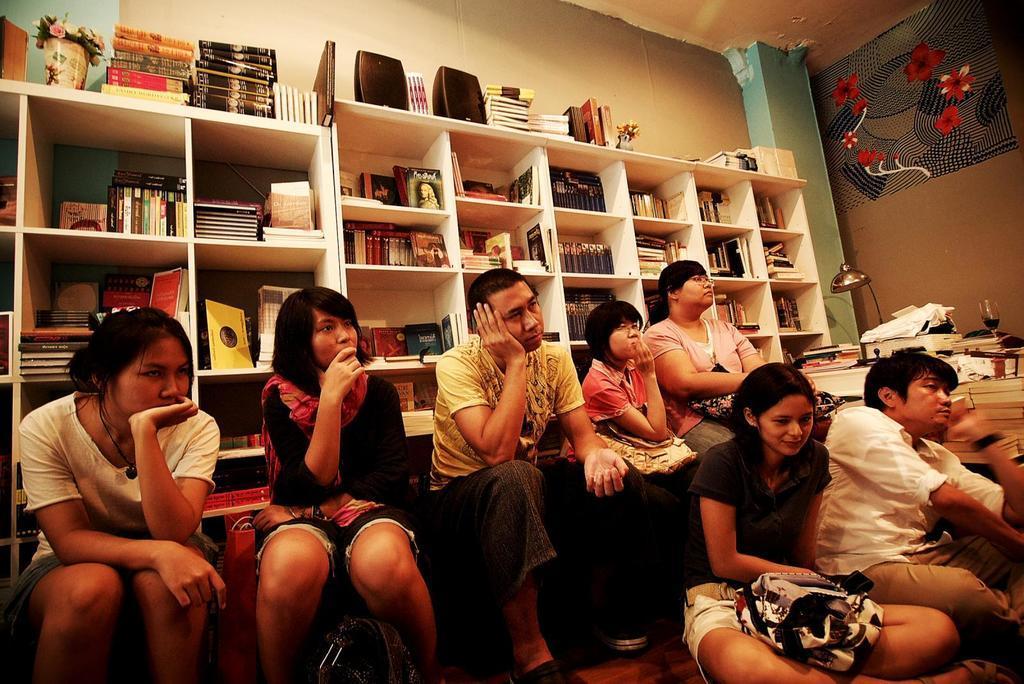Describe this image in one or two sentences. There is a group of persons sitting as we can see at the bottom of this image. There are some books kept in the racks in the background. We can see there is a wall at the top of this image. There are some books and a lamp, a glass in kept on a table on the right side of this image. 